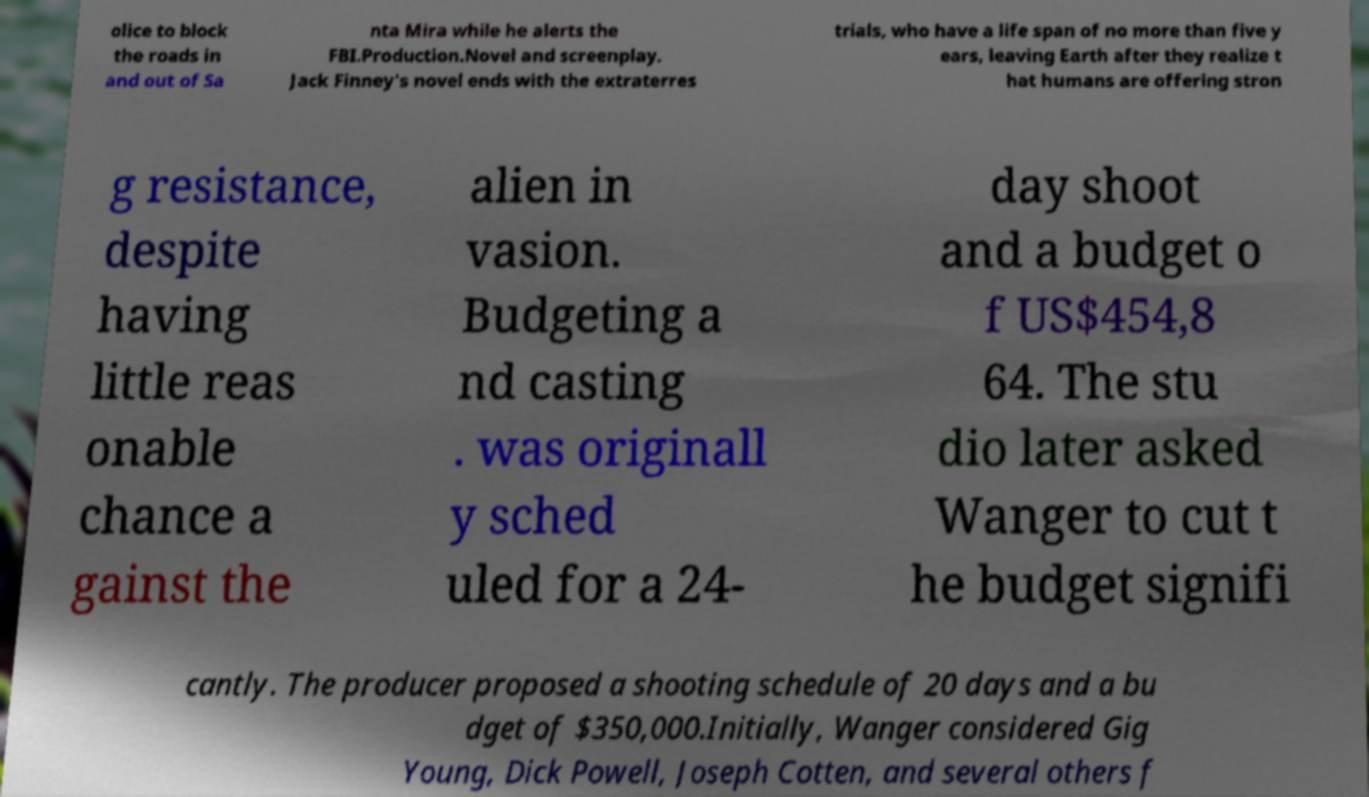There's text embedded in this image that I need extracted. Can you transcribe it verbatim? olice to block the roads in and out of Sa nta Mira while he alerts the FBI.Production.Novel and screenplay. Jack Finney's novel ends with the extraterres trials, who have a life span of no more than five y ears, leaving Earth after they realize t hat humans are offering stron g resistance, despite having little reas onable chance a gainst the alien in vasion. Budgeting a nd casting . was originall y sched uled for a 24- day shoot and a budget o f US$454,8 64. The stu dio later asked Wanger to cut t he budget signifi cantly. The producer proposed a shooting schedule of 20 days and a bu dget of $350,000.Initially, Wanger considered Gig Young, Dick Powell, Joseph Cotten, and several others f 